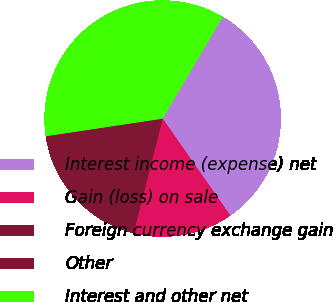Convert chart to OTSL. <chart><loc_0><loc_0><loc_500><loc_500><pie_chart><fcel>Interest income (expense) net<fcel>Gain (loss) on sale<fcel>Foreign currency exchange gain<fcel>Other<fcel>Interest and other net<nl><fcel>31.81%<fcel>13.66%<fcel>17.09%<fcel>1.57%<fcel>35.86%<nl></chart> 